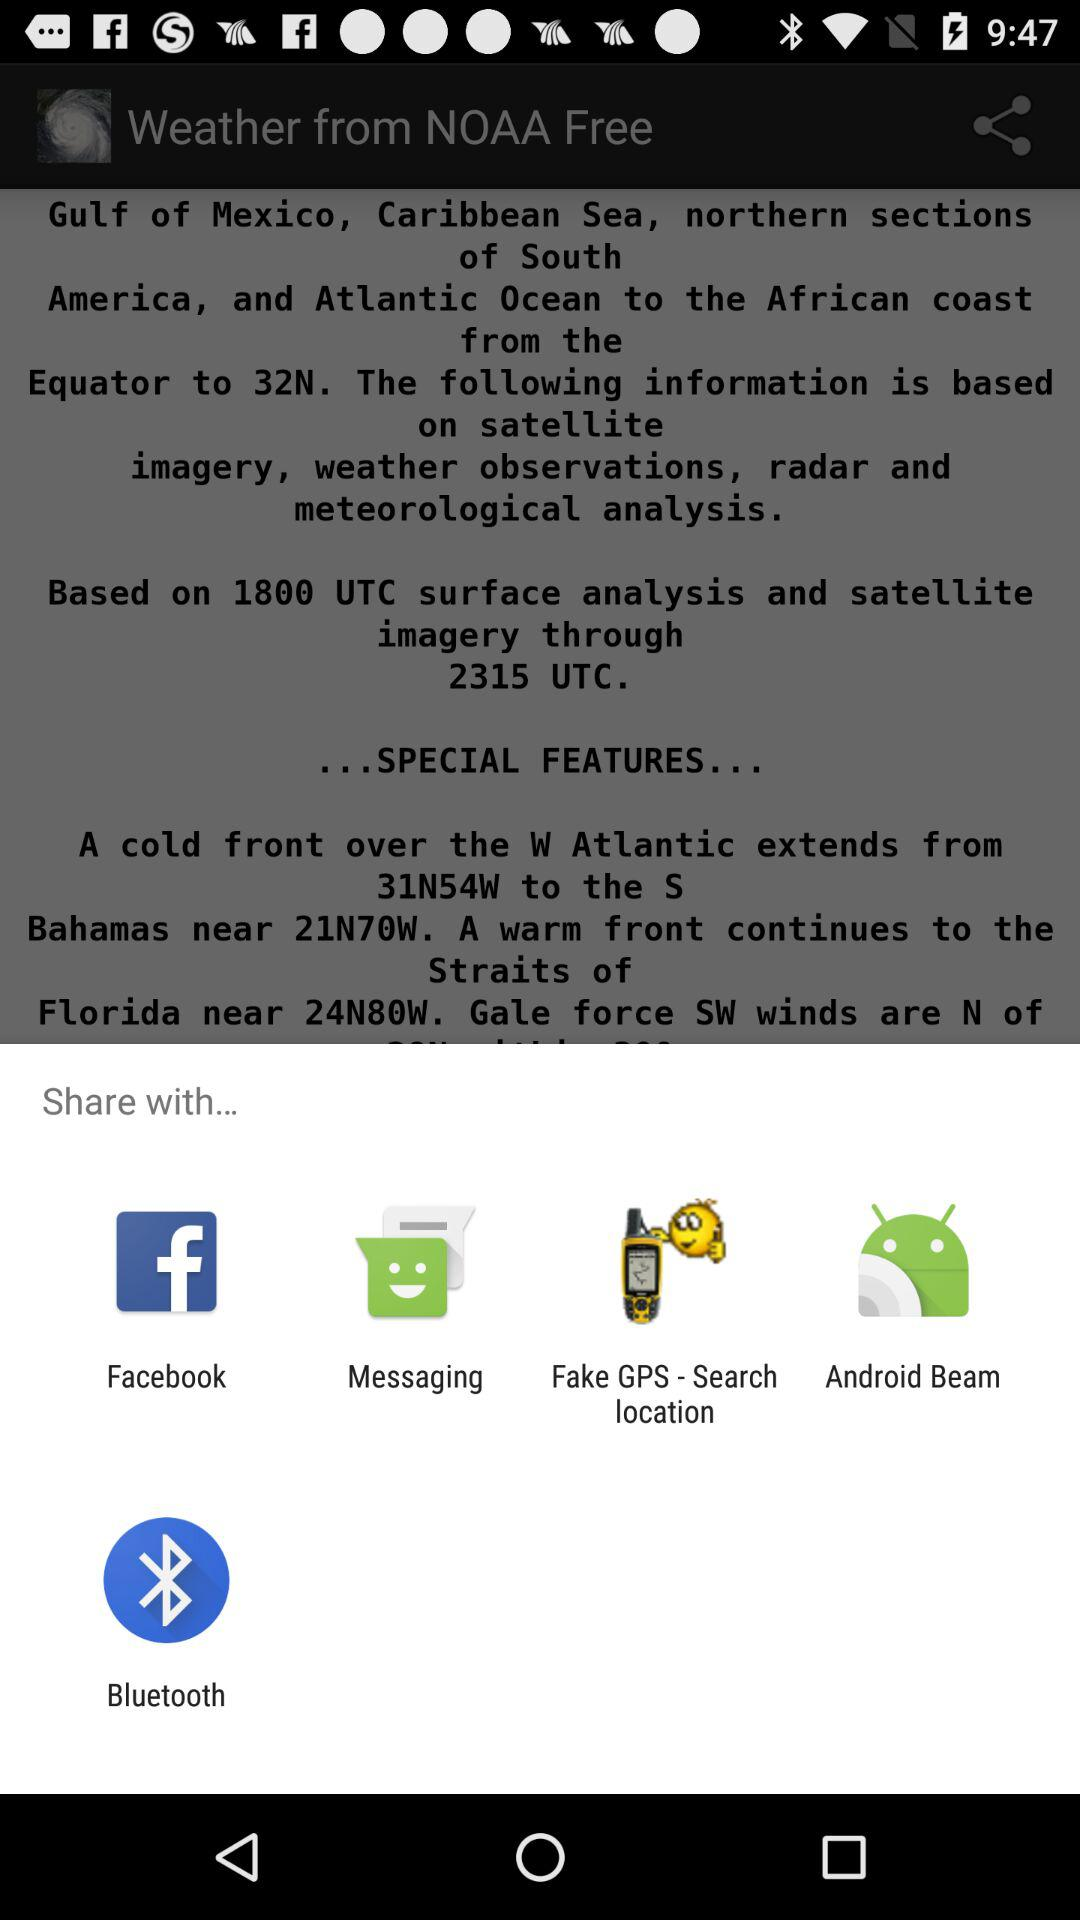What is the name of the application? The name of the application is "Weather from NOAA Free". 